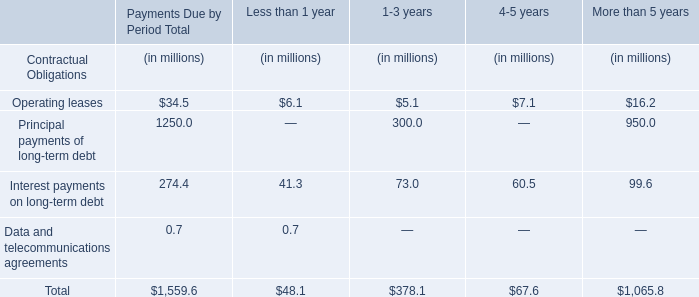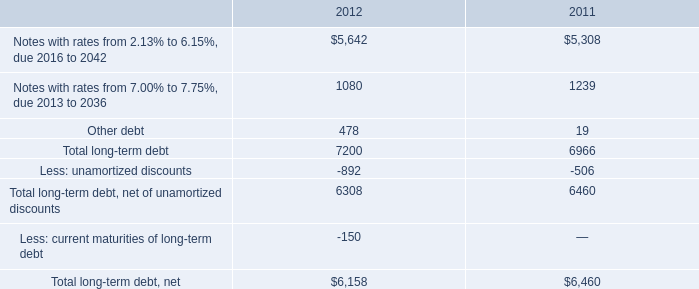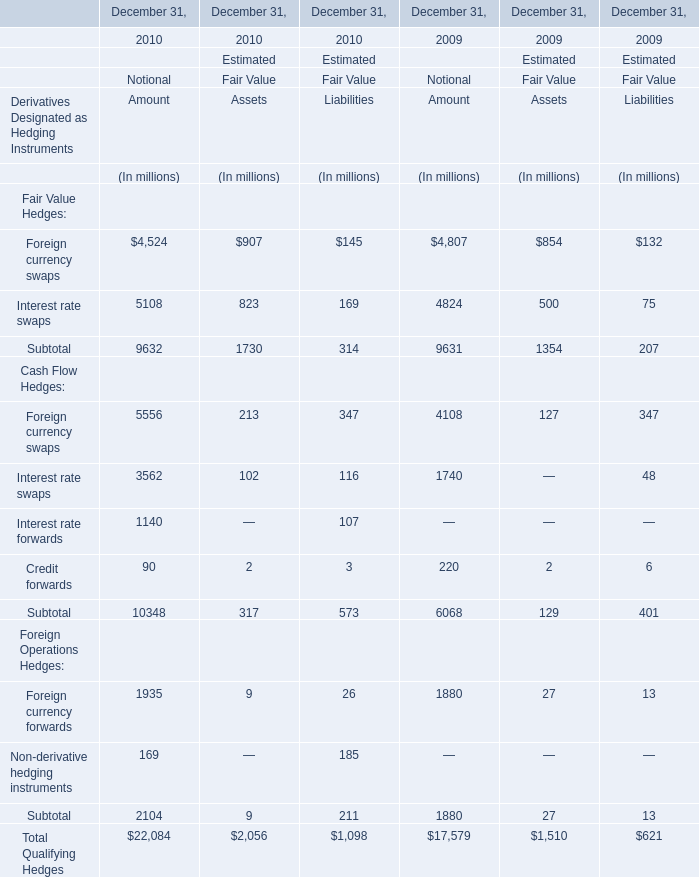what is the percentage change in interest payments from 2010 to 2011? 
Computations: ((326 - 337) / 337)
Answer: -0.03264. in 2012 what was the percentage of the premium apid to the exchange for outstanding notes exchanged 
Computations: (393 / 1.2)
Answer: 327.5. What's the growth rate of Interest rate swaps for Notional in 2009 for Notional ? 
Computations: ((5108 - 4824) / 4824)
Answer: 0.05887. 